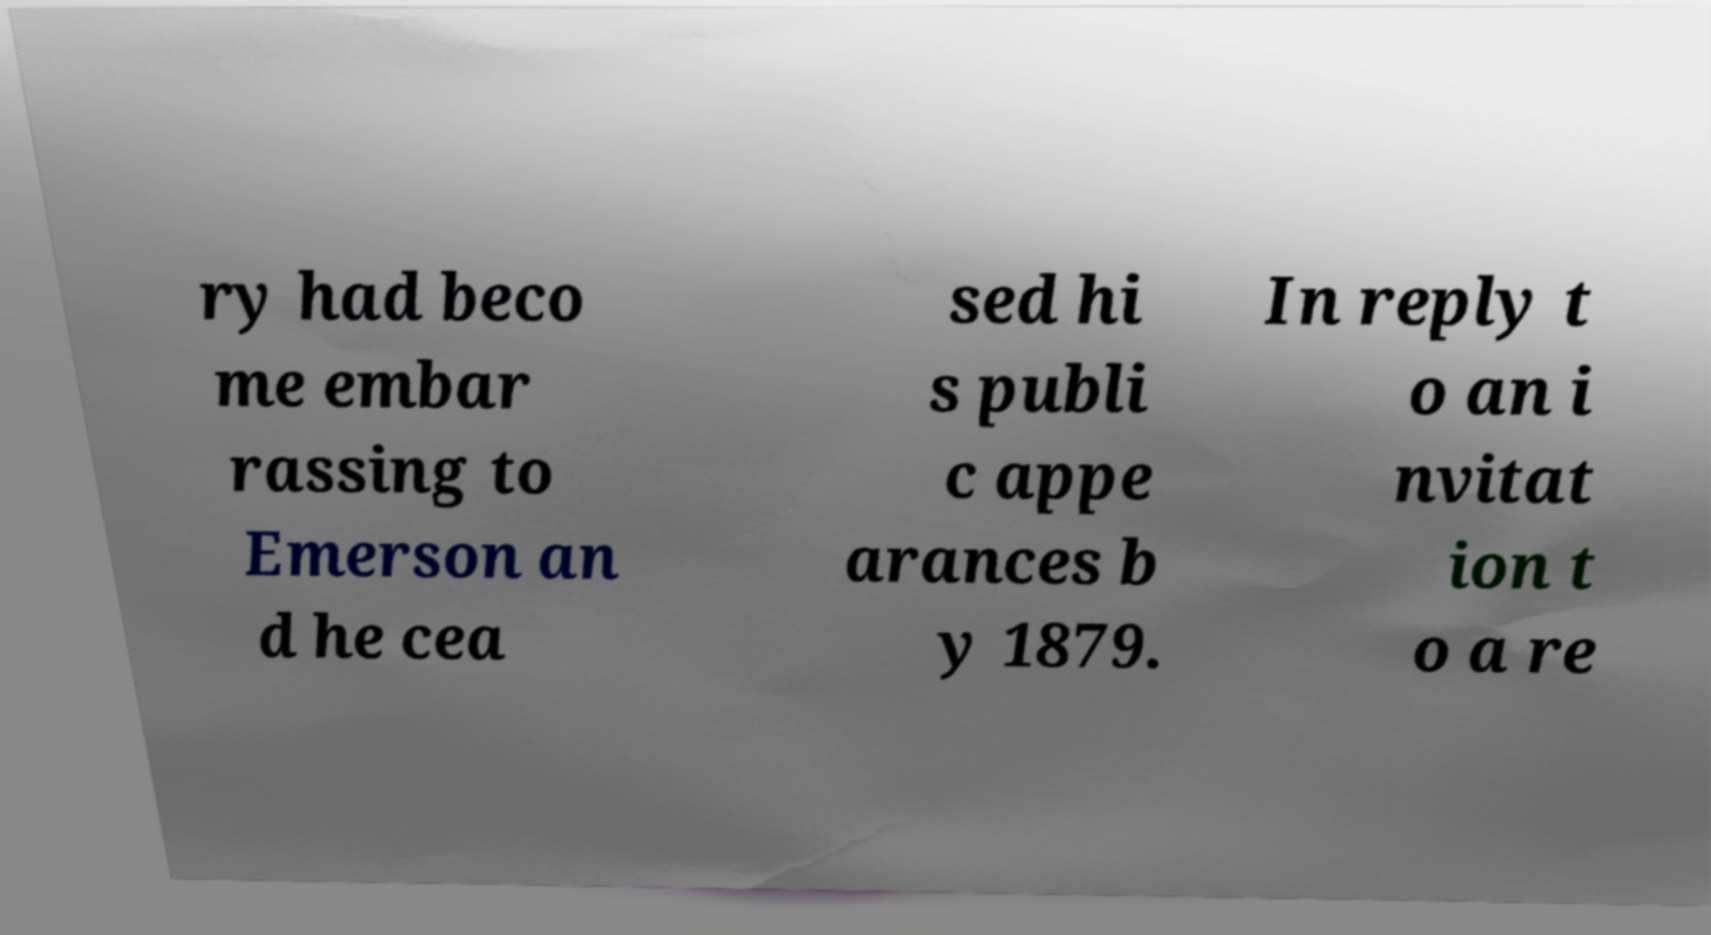What messages or text are displayed in this image? I need them in a readable, typed format. ry had beco me embar rassing to Emerson an d he cea sed hi s publi c appe arances b y 1879. In reply t o an i nvitat ion t o a re 